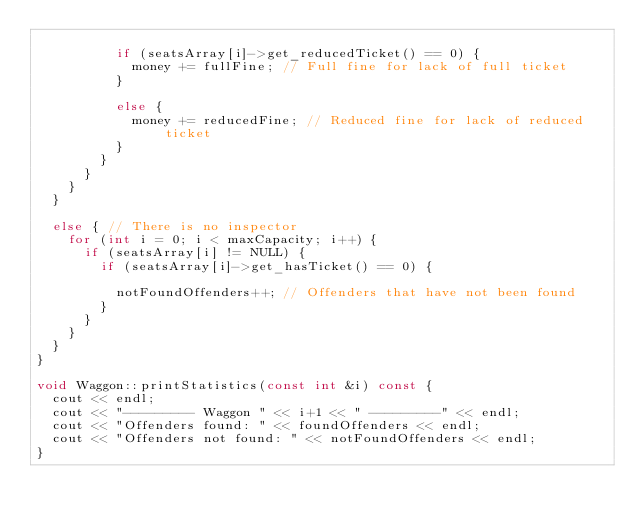<code> <loc_0><loc_0><loc_500><loc_500><_C++_>
					if (seatsArray[i]->get_reducedTicket() == 0) {
						money += fullFine; // Full fine for lack of full ticket
					}

					else {
						money += reducedFine; // Reduced fine for lack of reduced ticket
					}
				}
			}
		}
	}

	else { // There is no inspector
		for (int i = 0; i < maxCapacity; i++) {
			if (seatsArray[i] != NULL) {
				if (seatsArray[i]->get_hasTicket() == 0) {

					notFoundOffenders++; // Offenders that have not been found
				}
			}
		}
	}
}

void Waggon::printStatistics(const int &i) const {
	cout << endl;
	cout << "--------- Waggon " << i+1 << " ---------" << endl;
	cout << "Offenders found: " << foundOffenders << endl;
	cout << "Offenders not found: " << notFoundOffenders << endl;
}</code> 